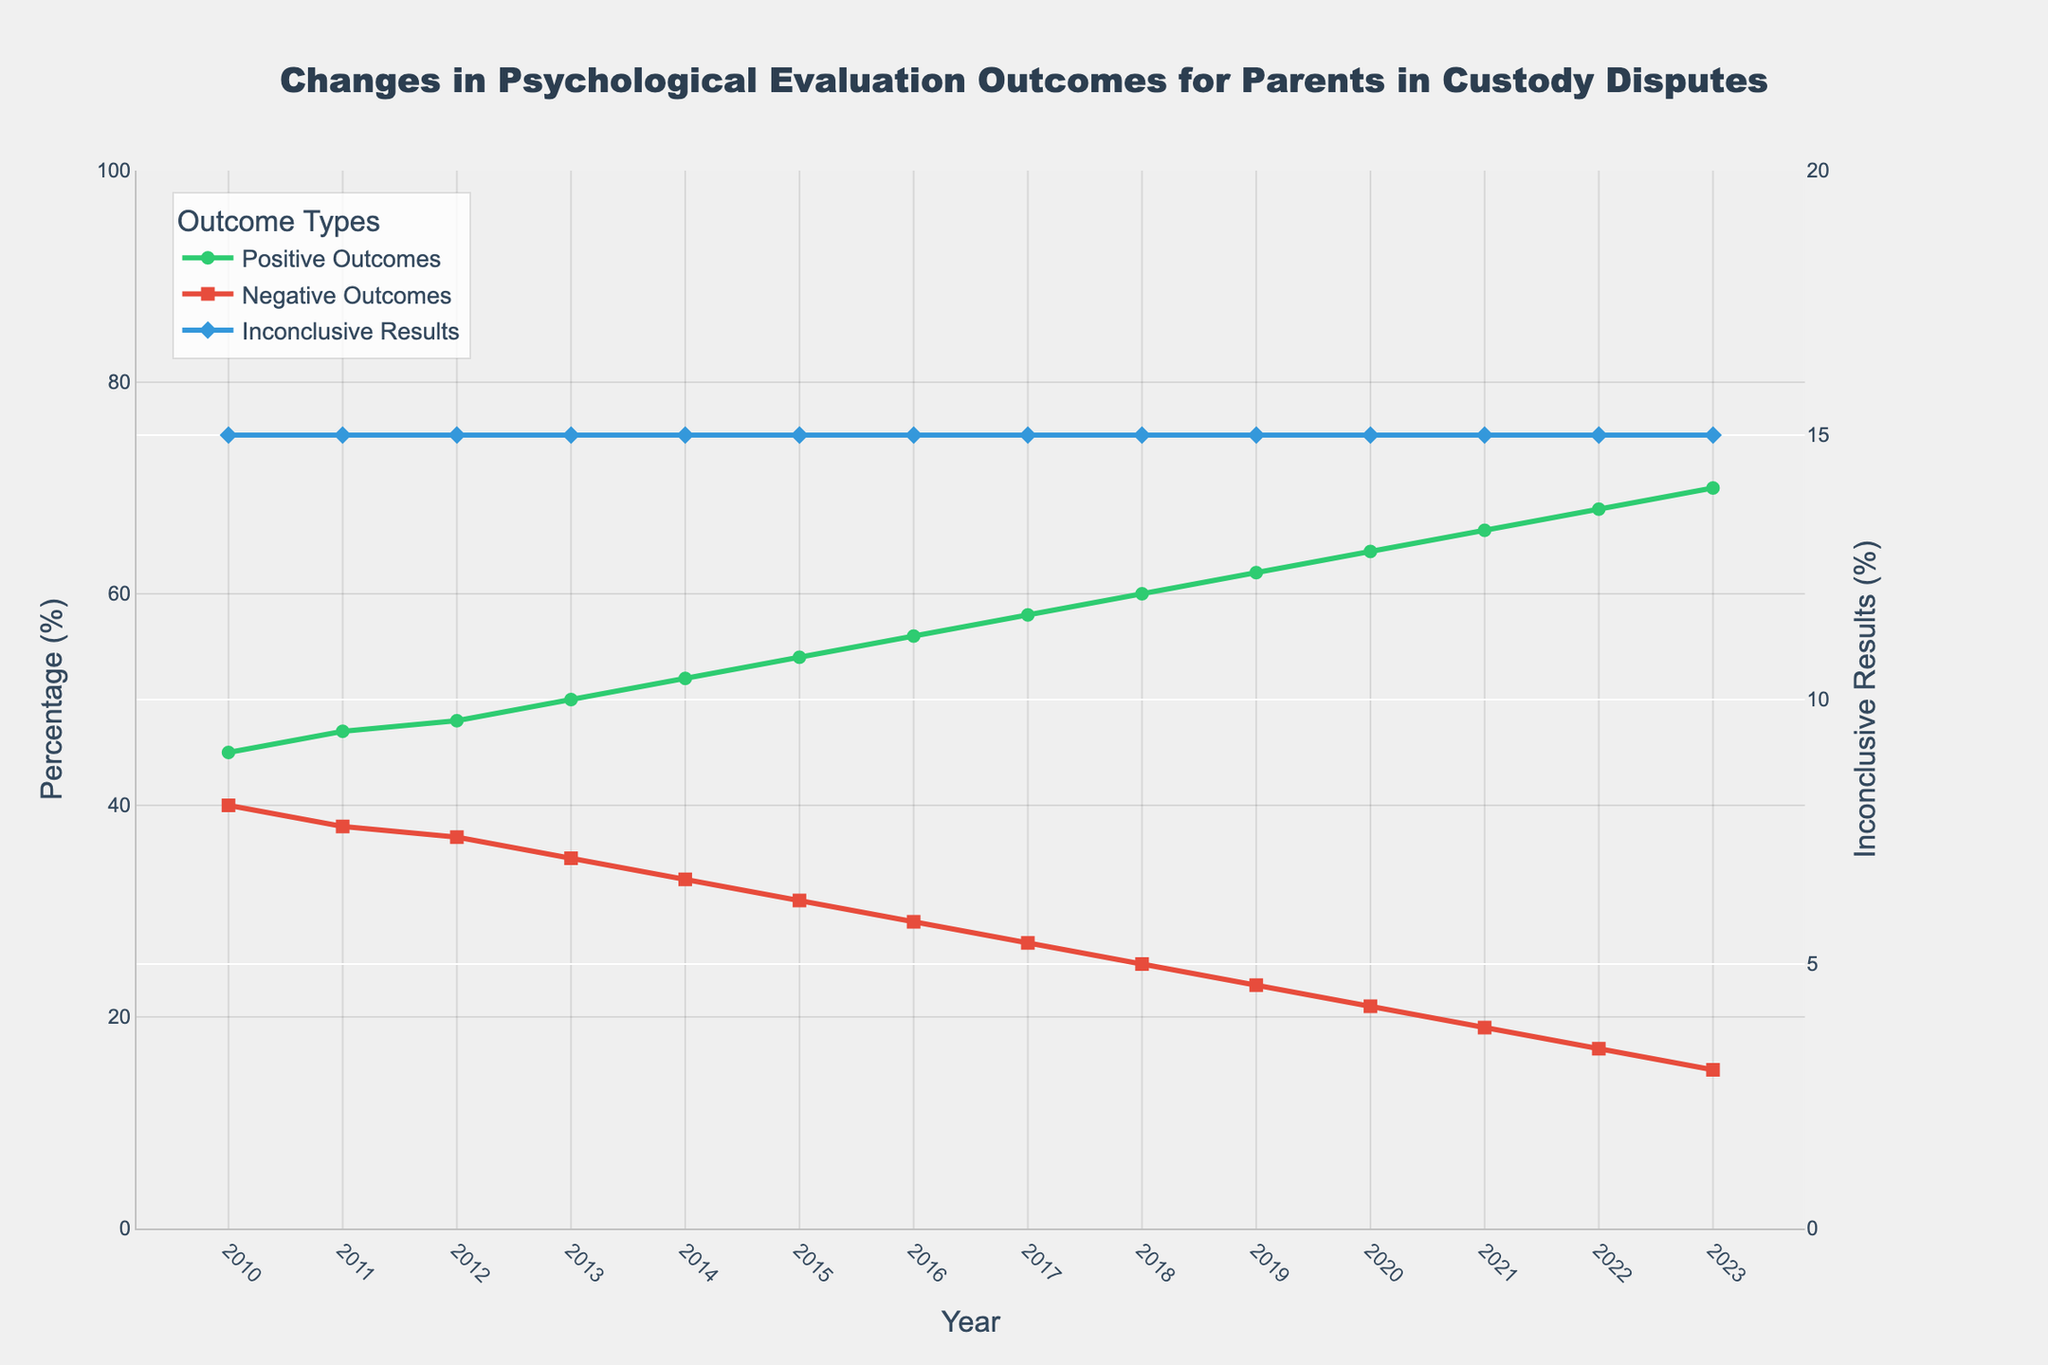What's the trend in Positive Outcomes between 2010 and 2023? The Positive Outcomes (%) appears to increase each year from 2010 to 2023, as indicated by the upward slope of the green line on the chart.
Answer: Upward trend How much did Positive Outcomes change from 2010 to 2023? Positive Outcomes increased from 45% in 2010 to 70% in 2023, calculated by subtracting the initial value from the final value (70 - 45).
Answer: 25% Which year saw an equal proportion of Positive and Negative Outcomes? In the year 2013, Positive Outcomes were 50% and Negative Outcomes were 35%, according to the graph. This year is closest to balanced proportions.
Answer: 2013 Compare the trend of Negative Outcomes to Positive Outcomes. Negative Outcomes (%) decreased from 40% in 2010 to 15% in 2023, while Positive Outcomes (%) increased in the same period. This is reflected by the downward slope of the red line and the upward slope of the green line.
Answer: Negative decreasing, Positive increasing What is the average percentage of Inconclusive Results between 2010 and 2023? Inconclusive Results remain constant at 15% each year from 2010 to 2023, as depicted by the flat blue line. To find the average, sum these identical percentages over the years and divide by the number of years, keeping the value at 15%.
Answer: 15% In which year did Positive Outcomes reach 60%? According to the graph, Positive Outcomes reached 60% in the year 2018. This can be observed by checking the value of the green line in 2018.
Answer: 2018 What's the difference between Positive and Negative Outcomes in 2023? In 2023, Positive Outcomes are at 70% and Negative Outcomes are at 15%. The difference is calculated by subtracting the latter from the former (70 - 15).
Answer: 55% Do Inconclusive Results show any variation over the years? The blue line representing Inconclusive Results (%) shows no variation from 2010 to 2023, remaining steady at 15% throughout the period.
Answer: No variation How did the percentage for Negative Outcomes change between 2014 and 2018? Negative Outcomes decreased from 33% in 2014 to 25% in 2018, calculated by the difference (33 - 25).
Answer: 8% decrease In which year was the difference between Positive and Negative Outcomes the smallest, and what was that difference? In 2010, Positive Outcomes were 45% and Negative Outcomes were 40%, making the difference 5%. This was the smallest difference in the years shown.
Answer: 2010, 5% 